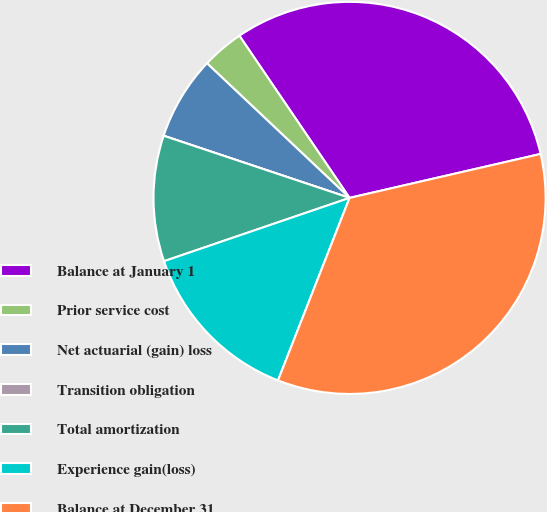Convert chart. <chart><loc_0><loc_0><loc_500><loc_500><pie_chart><fcel>Balance at January 1<fcel>Prior service cost<fcel>Net actuarial (gain) loss<fcel>Transition obligation<fcel>Total amortization<fcel>Experience gain(loss)<fcel>Balance at December 31<nl><fcel>30.9%<fcel>3.46%<fcel>6.91%<fcel>0.0%<fcel>10.37%<fcel>13.82%<fcel>34.55%<nl></chart> 